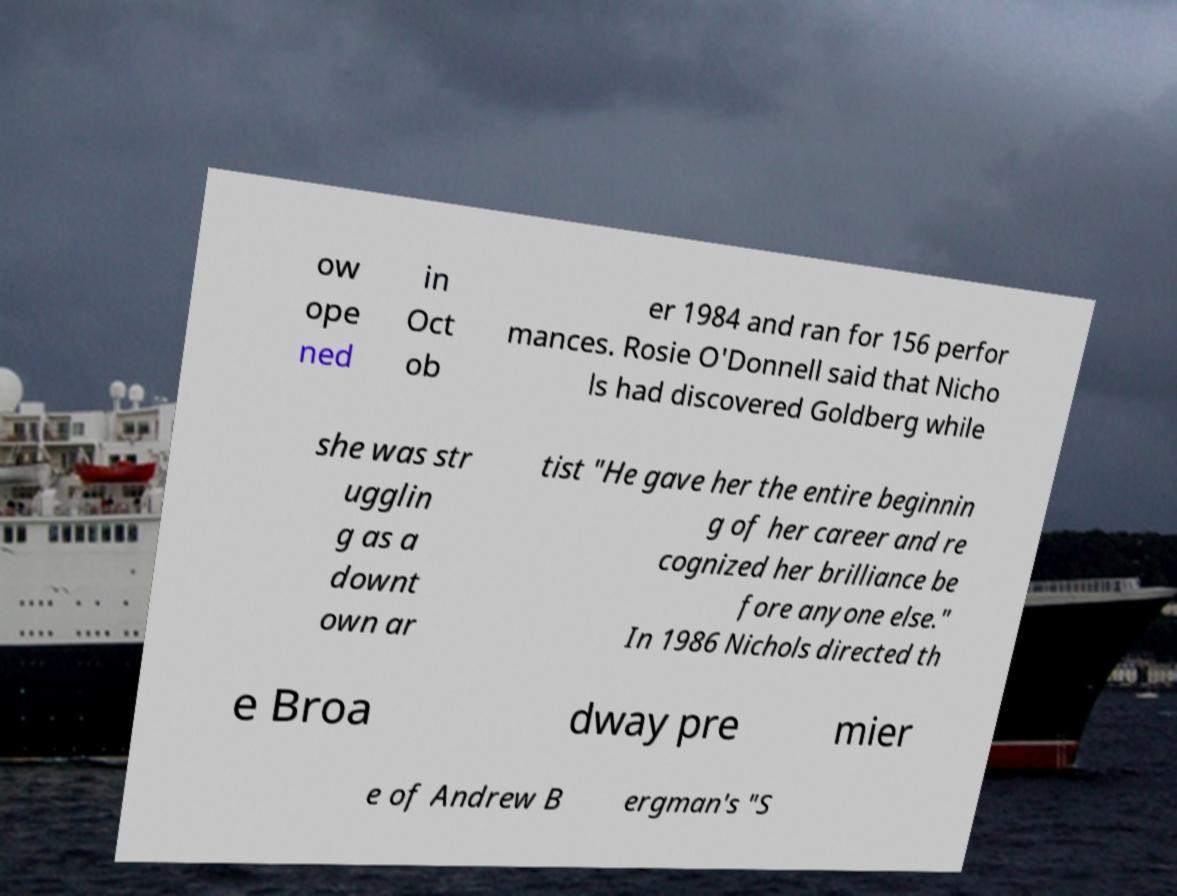Can you read and provide the text displayed in the image?This photo seems to have some interesting text. Can you extract and type it out for me? ow ope ned in Oct ob er 1984 and ran for 156 perfor mances. Rosie O'Donnell said that Nicho ls had discovered Goldberg while she was str ugglin g as a downt own ar tist "He gave her the entire beginnin g of her career and re cognized her brilliance be fore anyone else." In 1986 Nichols directed th e Broa dway pre mier e of Andrew B ergman's "S 